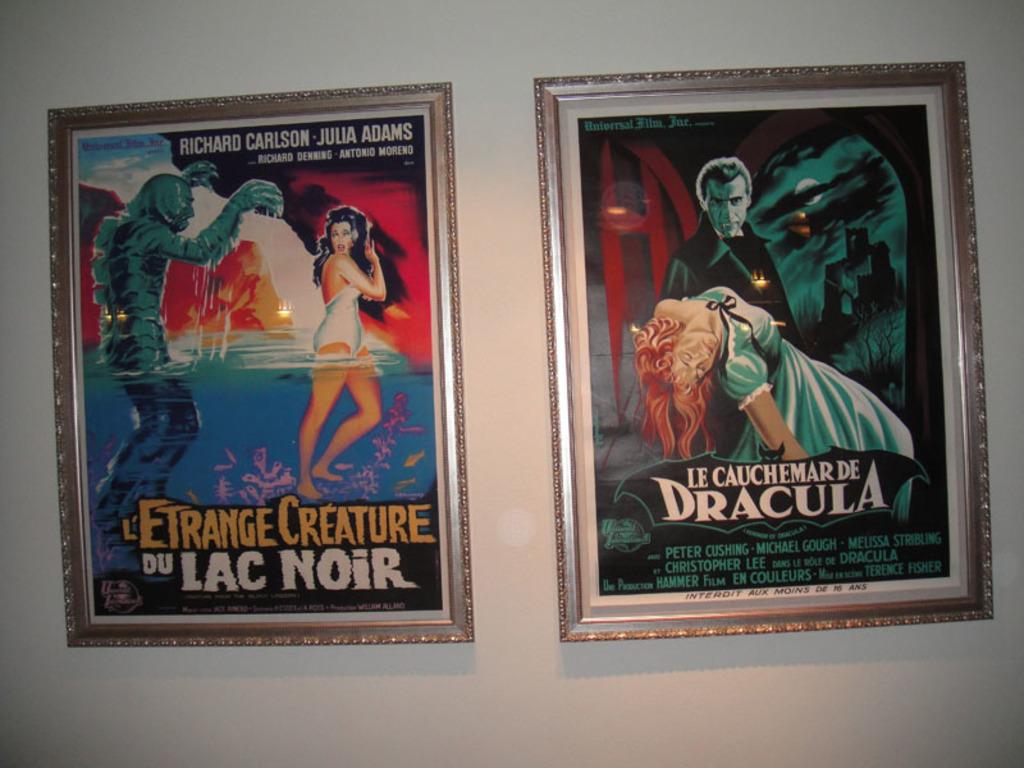Who is that on the movie poster on the right?
Keep it short and to the point. Dracula. Who is the male star of the poster on the left?
Provide a succinct answer. Richard carlson. 